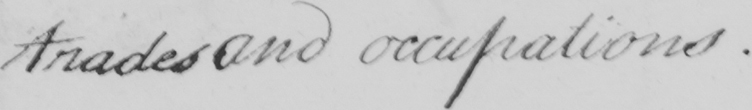Please provide the text content of this handwritten line. trades and occupations . 